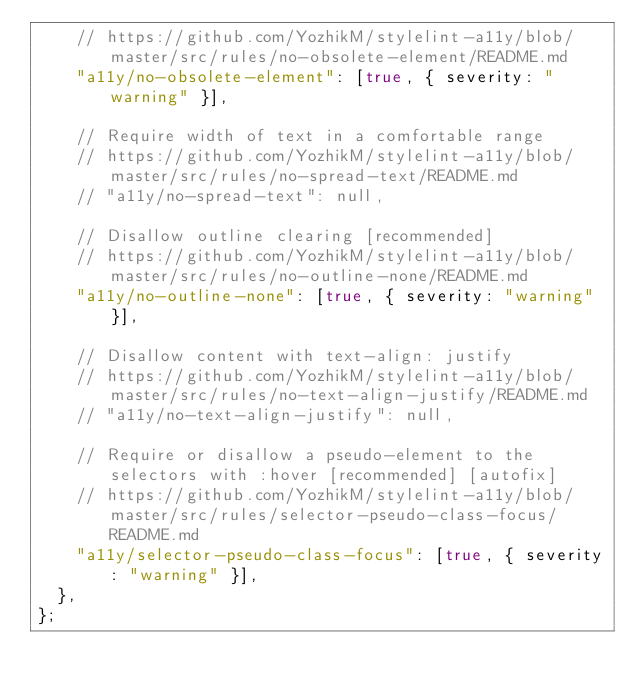<code> <loc_0><loc_0><loc_500><loc_500><_JavaScript_>    // https://github.com/YozhikM/stylelint-a11y/blob/master/src/rules/no-obsolete-element/README.md
    "a11y/no-obsolete-element": [true, { severity: "warning" }],

    // Require width of text in a comfortable range
    // https://github.com/YozhikM/stylelint-a11y/blob/master/src/rules/no-spread-text/README.md
    // "a11y/no-spread-text": null,

    // Disallow outline clearing [recommended]
    // https://github.com/YozhikM/stylelint-a11y/blob/master/src/rules/no-outline-none/README.md
    "a11y/no-outline-none": [true, { severity: "warning" }],

    // Disallow content with text-align: justify
    // https://github.com/YozhikM/stylelint-a11y/blob/master/src/rules/no-text-align-justify/README.md
    // "a11y/no-text-align-justify": null,

    // Require or disallow a pseudo-element to the selectors with :hover [recommended] [autofix]
    // https://github.com/YozhikM/stylelint-a11y/blob/master/src/rules/selector-pseudo-class-focus/README.md
    "a11y/selector-pseudo-class-focus": [true, { severity: "warning" }],
  },
};
</code> 